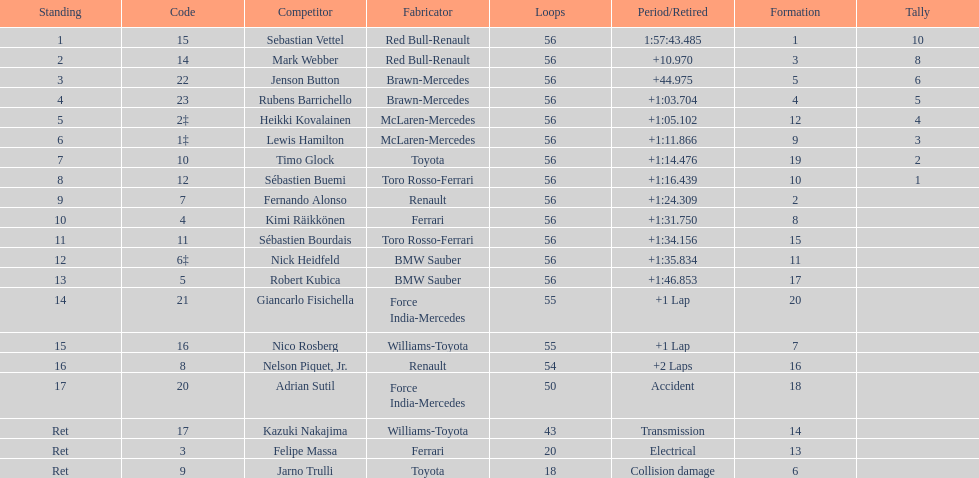Heikki kovalainen and lewis hamilton both had which constructor? McLaren-Mercedes. Help me parse the entirety of this table. {'header': ['Standing', 'Code', 'Competitor', 'Fabricator', 'Loops', 'Period/Retired', 'Formation', 'Tally'], 'rows': [['1', '15', 'Sebastian Vettel', 'Red Bull-Renault', '56', '1:57:43.485', '1', '10'], ['2', '14', 'Mark Webber', 'Red Bull-Renault', '56', '+10.970', '3', '8'], ['3', '22', 'Jenson Button', 'Brawn-Mercedes', '56', '+44.975', '5', '6'], ['4', '23', 'Rubens Barrichello', 'Brawn-Mercedes', '56', '+1:03.704', '4', '5'], ['5', '2‡', 'Heikki Kovalainen', 'McLaren-Mercedes', '56', '+1:05.102', '12', '4'], ['6', '1‡', 'Lewis Hamilton', 'McLaren-Mercedes', '56', '+1:11.866', '9', '3'], ['7', '10', 'Timo Glock', 'Toyota', '56', '+1:14.476', '19', '2'], ['8', '12', 'Sébastien Buemi', 'Toro Rosso-Ferrari', '56', '+1:16.439', '10', '1'], ['9', '7', 'Fernando Alonso', 'Renault', '56', '+1:24.309', '2', ''], ['10', '4', 'Kimi Räikkönen', 'Ferrari', '56', '+1:31.750', '8', ''], ['11', '11', 'Sébastien Bourdais', 'Toro Rosso-Ferrari', '56', '+1:34.156', '15', ''], ['12', '6‡', 'Nick Heidfeld', 'BMW Sauber', '56', '+1:35.834', '11', ''], ['13', '5', 'Robert Kubica', 'BMW Sauber', '56', '+1:46.853', '17', ''], ['14', '21', 'Giancarlo Fisichella', 'Force India-Mercedes', '55', '+1 Lap', '20', ''], ['15', '16', 'Nico Rosberg', 'Williams-Toyota', '55', '+1 Lap', '7', ''], ['16', '8', 'Nelson Piquet, Jr.', 'Renault', '54', '+2 Laps', '16', ''], ['17', '20', 'Adrian Sutil', 'Force India-Mercedes', '50', 'Accident', '18', ''], ['Ret', '17', 'Kazuki Nakajima', 'Williams-Toyota', '43', 'Transmission', '14', ''], ['Ret', '3', 'Felipe Massa', 'Ferrari', '20', 'Electrical', '13', ''], ['Ret', '9', 'Jarno Trulli', 'Toyota', '18', 'Collision damage', '6', '']]} 